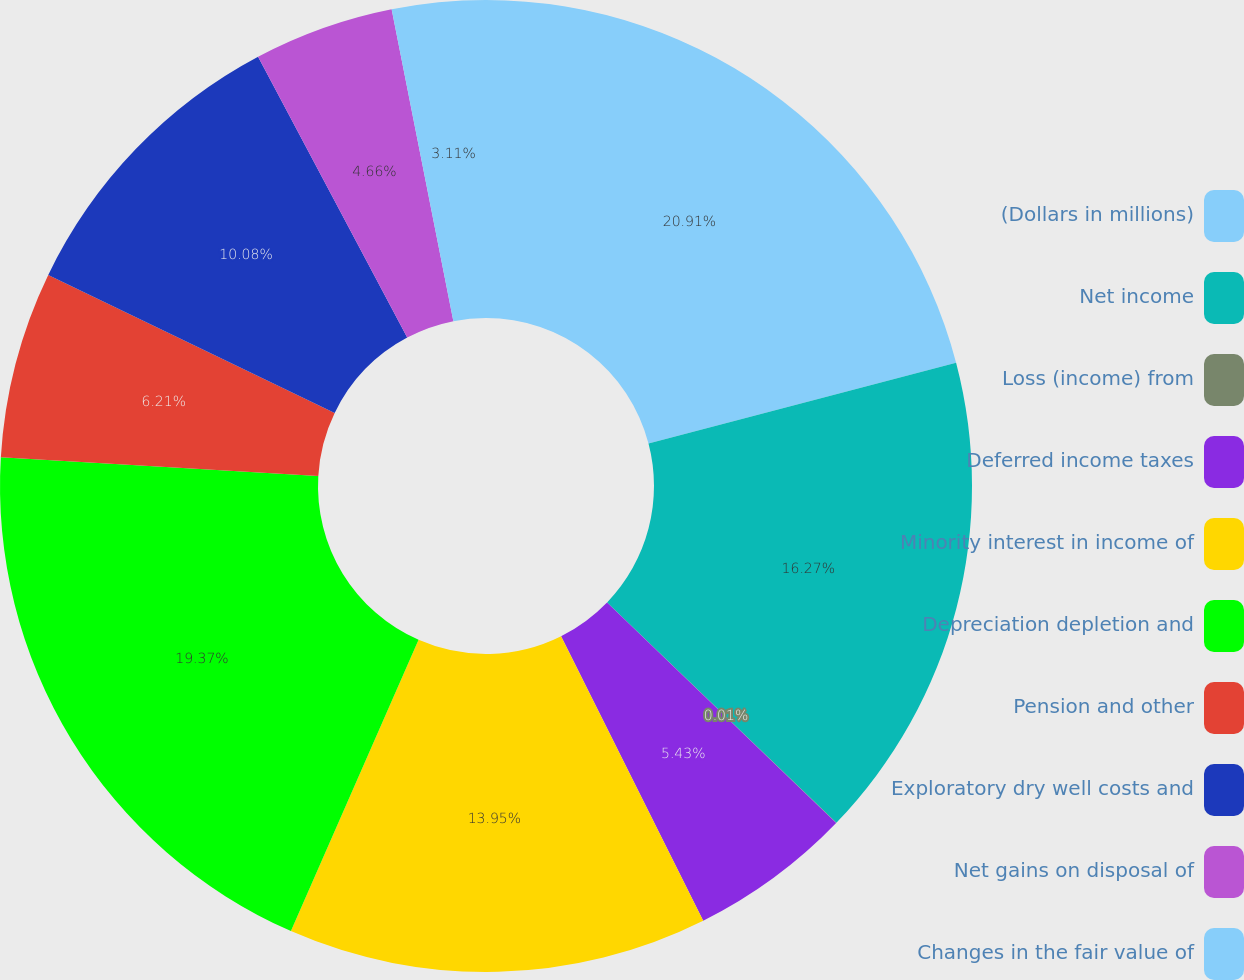Convert chart to OTSL. <chart><loc_0><loc_0><loc_500><loc_500><pie_chart><fcel>(Dollars in millions)<fcel>Net income<fcel>Loss (income) from<fcel>Deferred income taxes<fcel>Minority interest in income of<fcel>Depreciation depletion and<fcel>Pension and other<fcel>Exploratory dry well costs and<fcel>Net gains on disposal of<fcel>Changes in the fair value of<nl><fcel>20.92%<fcel>16.27%<fcel>0.01%<fcel>5.43%<fcel>13.95%<fcel>19.37%<fcel>6.21%<fcel>10.08%<fcel>4.66%<fcel>3.11%<nl></chart> 